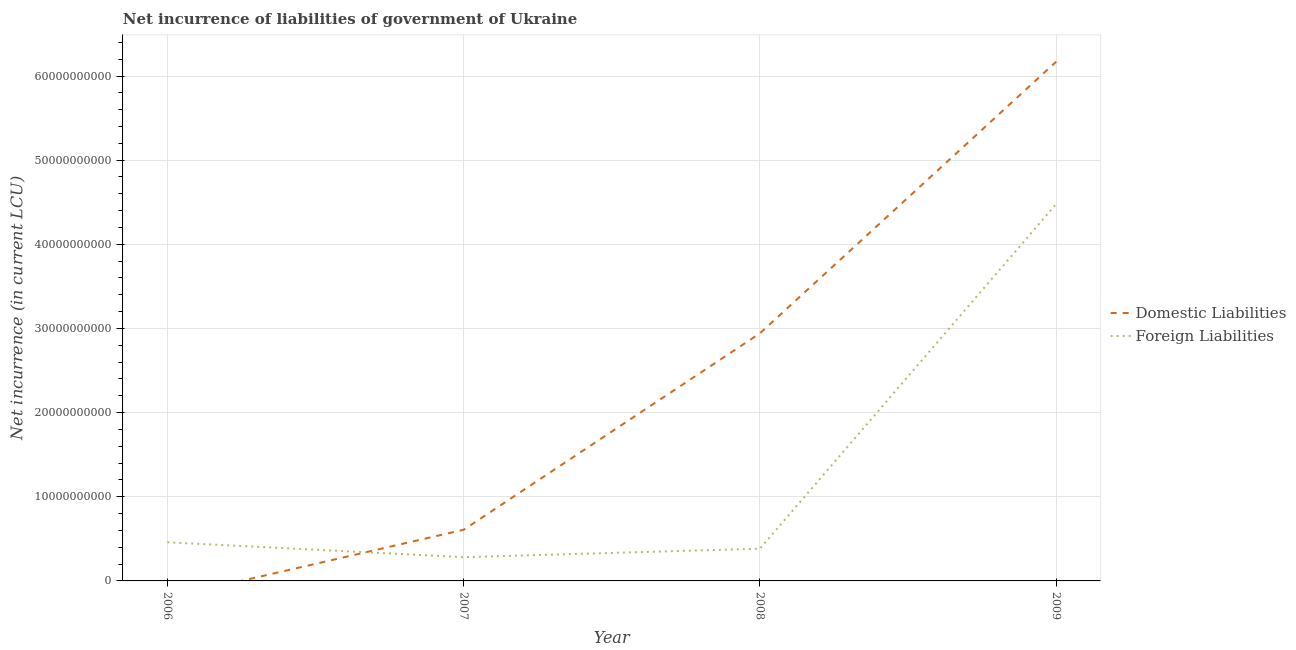How many different coloured lines are there?
Give a very brief answer. 2. What is the net incurrence of foreign liabilities in 2009?
Provide a succinct answer. 4.48e+1. Across all years, what is the maximum net incurrence of domestic liabilities?
Provide a short and direct response. 6.17e+1. Across all years, what is the minimum net incurrence of foreign liabilities?
Give a very brief answer. 2.82e+09. In which year was the net incurrence of domestic liabilities maximum?
Offer a very short reply. 2009. What is the total net incurrence of domestic liabilities in the graph?
Ensure brevity in your answer.  9.72e+1. What is the difference between the net incurrence of foreign liabilities in 2007 and that in 2008?
Offer a very short reply. -1.01e+09. What is the difference between the net incurrence of domestic liabilities in 2009 and the net incurrence of foreign liabilities in 2007?
Keep it short and to the point. 5.89e+1. What is the average net incurrence of foreign liabilities per year?
Your answer should be compact. 1.40e+1. In the year 2007, what is the difference between the net incurrence of domestic liabilities and net incurrence of foreign liabilities?
Your answer should be very brief. 3.26e+09. In how many years, is the net incurrence of domestic liabilities greater than 30000000000 LCU?
Your answer should be very brief. 1. What is the ratio of the net incurrence of foreign liabilities in 2006 to that in 2009?
Make the answer very short. 0.1. Is the net incurrence of foreign liabilities in 2008 less than that in 2009?
Offer a very short reply. Yes. Is the difference between the net incurrence of foreign liabilities in 2008 and 2009 greater than the difference between the net incurrence of domestic liabilities in 2008 and 2009?
Provide a short and direct response. No. What is the difference between the highest and the second highest net incurrence of foreign liabilities?
Give a very brief answer. 4.02e+1. What is the difference between the highest and the lowest net incurrence of foreign liabilities?
Your answer should be very brief. 4.20e+1. In how many years, is the net incurrence of foreign liabilities greater than the average net incurrence of foreign liabilities taken over all years?
Ensure brevity in your answer.  1. Does the net incurrence of domestic liabilities monotonically increase over the years?
Give a very brief answer. Yes. Is the net incurrence of domestic liabilities strictly less than the net incurrence of foreign liabilities over the years?
Your answer should be compact. No. How many years are there in the graph?
Keep it short and to the point. 4. Does the graph contain any zero values?
Your response must be concise. Yes. Does the graph contain grids?
Your response must be concise. Yes. How many legend labels are there?
Your answer should be compact. 2. How are the legend labels stacked?
Offer a terse response. Vertical. What is the title of the graph?
Make the answer very short. Net incurrence of liabilities of government of Ukraine. What is the label or title of the Y-axis?
Your response must be concise. Net incurrence (in current LCU). What is the Net incurrence (in current LCU) of Domestic Liabilities in 2006?
Keep it short and to the point. 0. What is the Net incurrence (in current LCU) in Foreign Liabilities in 2006?
Your answer should be very brief. 4.59e+09. What is the Net incurrence (in current LCU) in Domestic Liabilities in 2007?
Ensure brevity in your answer.  6.08e+09. What is the Net incurrence (in current LCU) in Foreign Liabilities in 2007?
Give a very brief answer. 2.82e+09. What is the Net incurrence (in current LCU) in Domestic Liabilities in 2008?
Your answer should be very brief. 2.94e+1. What is the Net incurrence (in current LCU) in Foreign Liabilities in 2008?
Offer a terse response. 3.83e+09. What is the Net incurrence (in current LCU) of Domestic Liabilities in 2009?
Your answer should be compact. 6.17e+1. What is the Net incurrence (in current LCU) of Foreign Liabilities in 2009?
Provide a succinct answer. 4.48e+1. Across all years, what is the maximum Net incurrence (in current LCU) of Domestic Liabilities?
Provide a short and direct response. 6.17e+1. Across all years, what is the maximum Net incurrence (in current LCU) of Foreign Liabilities?
Provide a succinct answer. 4.48e+1. Across all years, what is the minimum Net incurrence (in current LCU) of Domestic Liabilities?
Offer a very short reply. 0. Across all years, what is the minimum Net incurrence (in current LCU) of Foreign Liabilities?
Your answer should be compact. 2.82e+09. What is the total Net incurrence (in current LCU) in Domestic Liabilities in the graph?
Offer a terse response. 9.72e+1. What is the total Net incurrence (in current LCU) in Foreign Liabilities in the graph?
Make the answer very short. 5.60e+1. What is the difference between the Net incurrence (in current LCU) of Foreign Liabilities in 2006 and that in 2007?
Offer a terse response. 1.77e+09. What is the difference between the Net incurrence (in current LCU) of Foreign Liabilities in 2006 and that in 2008?
Provide a short and direct response. 7.64e+08. What is the difference between the Net incurrence (in current LCU) in Foreign Liabilities in 2006 and that in 2009?
Ensure brevity in your answer.  -4.02e+1. What is the difference between the Net incurrence (in current LCU) in Domestic Liabilities in 2007 and that in 2008?
Make the answer very short. -2.33e+1. What is the difference between the Net incurrence (in current LCU) of Foreign Liabilities in 2007 and that in 2008?
Offer a very short reply. -1.01e+09. What is the difference between the Net incurrence (in current LCU) in Domestic Liabilities in 2007 and that in 2009?
Provide a short and direct response. -5.56e+1. What is the difference between the Net incurrence (in current LCU) of Foreign Liabilities in 2007 and that in 2009?
Offer a very short reply. -4.20e+1. What is the difference between the Net incurrence (in current LCU) of Domestic Liabilities in 2008 and that in 2009?
Offer a terse response. -3.23e+1. What is the difference between the Net incurrence (in current LCU) of Foreign Liabilities in 2008 and that in 2009?
Your answer should be compact. -4.10e+1. What is the difference between the Net incurrence (in current LCU) in Domestic Liabilities in 2007 and the Net incurrence (in current LCU) in Foreign Liabilities in 2008?
Your answer should be very brief. 2.25e+09. What is the difference between the Net incurrence (in current LCU) of Domestic Liabilities in 2007 and the Net incurrence (in current LCU) of Foreign Liabilities in 2009?
Ensure brevity in your answer.  -3.87e+1. What is the difference between the Net incurrence (in current LCU) in Domestic Liabilities in 2008 and the Net incurrence (in current LCU) in Foreign Liabilities in 2009?
Keep it short and to the point. -1.54e+1. What is the average Net incurrence (in current LCU) of Domestic Liabilities per year?
Offer a terse response. 2.43e+1. What is the average Net incurrence (in current LCU) in Foreign Liabilities per year?
Make the answer very short. 1.40e+1. In the year 2007, what is the difference between the Net incurrence (in current LCU) of Domestic Liabilities and Net incurrence (in current LCU) of Foreign Liabilities?
Keep it short and to the point. 3.26e+09. In the year 2008, what is the difference between the Net incurrence (in current LCU) of Domestic Liabilities and Net incurrence (in current LCU) of Foreign Liabilities?
Provide a succinct answer. 2.56e+1. In the year 2009, what is the difference between the Net incurrence (in current LCU) in Domestic Liabilities and Net incurrence (in current LCU) in Foreign Liabilities?
Your answer should be compact. 1.69e+1. What is the ratio of the Net incurrence (in current LCU) of Foreign Liabilities in 2006 to that in 2007?
Give a very brief answer. 1.63. What is the ratio of the Net incurrence (in current LCU) in Foreign Liabilities in 2006 to that in 2008?
Offer a terse response. 1.2. What is the ratio of the Net incurrence (in current LCU) of Foreign Liabilities in 2006 to that in 2009?
Your answer should be very brief. 0.1. What is the ratio of the Net incurrence (in current LCU) of Domestic Liabilities in 2007 to that in 2008?
Make the answer very short. 0.21. What is the ratio of the Net incurrence (in current LCU) of Foreign Liabilities in 2007 to that in 2008?
Your answer should be very brief. 0.74. What is the ratio of the Net incurrence (in current LCU) in Domestic Liabilities in 2007 to that in 2009?
Offer a very short reply. 0.1. What is the ratio of the Net incurrence (in current LCU) of Foreign Liabilities in 2007 to that in 2009?
Provide a short and direct response. 0.06. What is the ratio of the Net incurrence (in current LCU) of Domestic Liabilities in 2008 to that in 2009?
Make the answer very short. 0.48. What is the ratio of the Net incurrence (in current LCU) of Foreign Liabilities in 2008 to that in 2009?
Ensure brevity in your answer.  0.09. What is the difference between the highest and the second highest Net incurrence (in current LCU) of Domestic Liabilities?
Your answer should be very brief. 3.23e+1. What is the difference between the highest and the second highest Net incurrence (in current LCU) in Foreign Liabilities?
Your answer should be compact. 4.02e+1. What is the difference between the highest and the lowest Net incurrence (in current LCU) in Domestic Liabilities?
Your answer should be compact. 6.17e+1. What is the difference between the highest and the lowest Net incurrence (in current LCU) in Foreign Liabilities?
Offer a very short reply. 4.20e+1. 